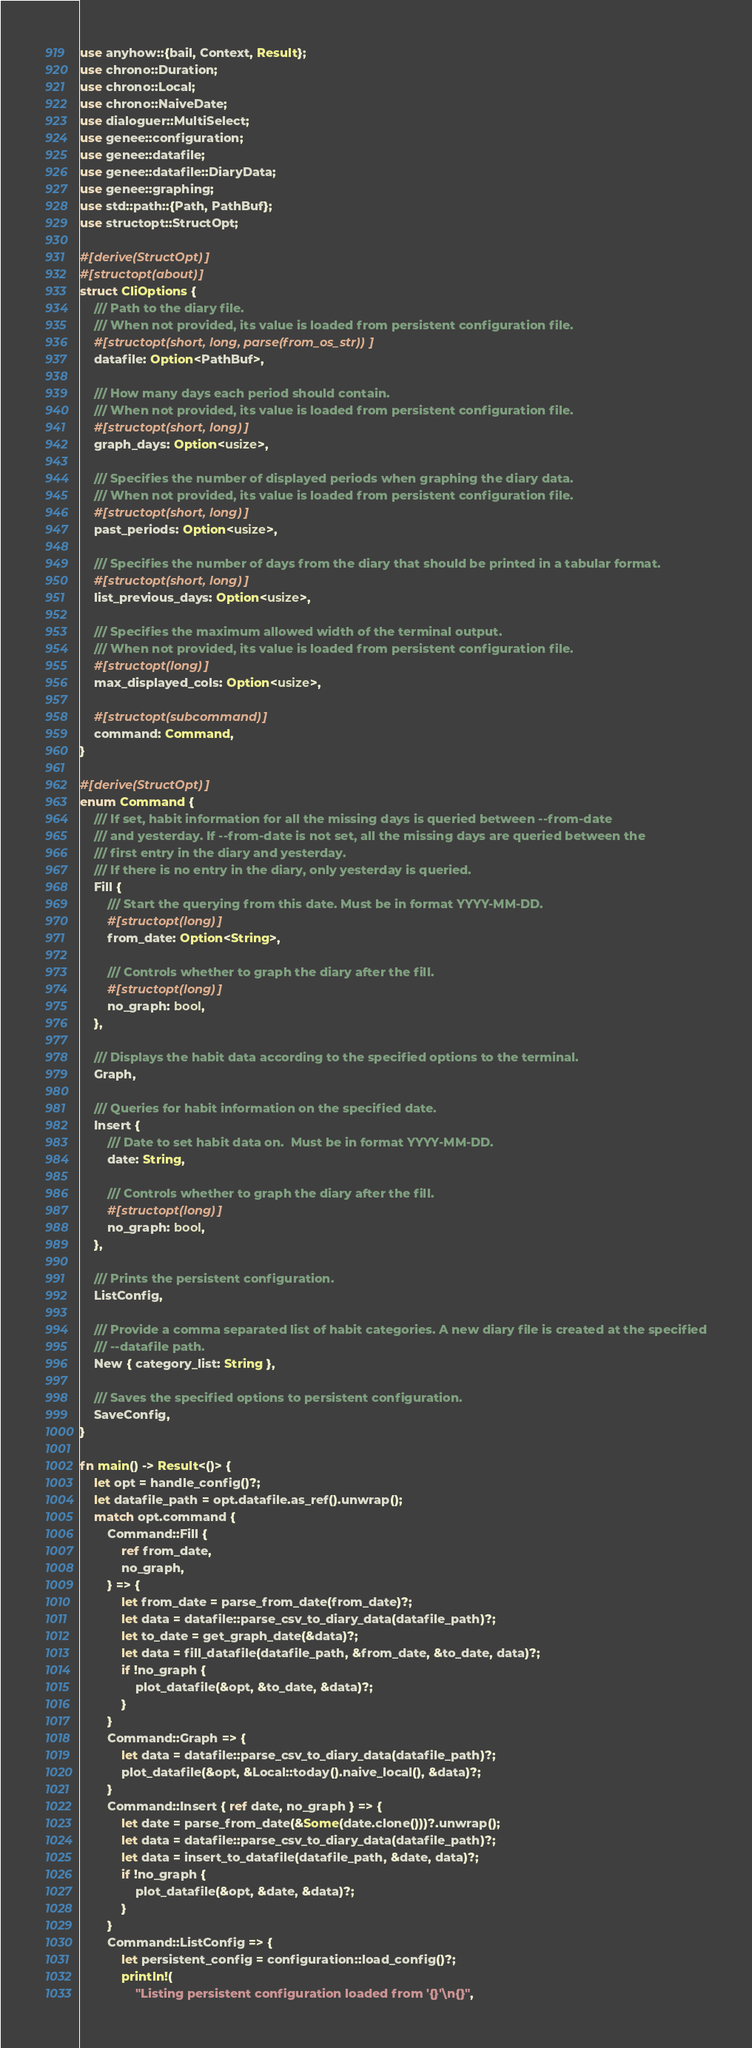Convert code to text. <code><loc_0><loc_0><loc_500><loc_500><_Rust_>use anyhow::{bail, Context, Result};
use chrono::Duration;
use chrono::Local;
use chrono::NaiveDate;
use dialoguer::MultiSelect;
use genee::configuration;
use genee::datafile;
use genee::datafile::DiaryData;
use genee::graphing;
use std::path::{Path, PathBuf};
use structopt::StructOpt;

#[derive(StructOpt)]
#[structopt(about)]
struct CliOptions {
    /// Path to the diary file.
    /// When not provided, its value is loaded from persistent configuration file.
    #[structopt(short, long, parse(from_os_str))]
    datafile: Option<PathBuf>,

    /// How many days each period should contain.
    /// When not provided, its value is loaded from persistent configuration file.
    #[structopt(short, long)]
    graph_days: Option<usize>,

    /// Specifies the number of displayed periods when graphing the diary data.
    /// When not provided, its value is loaded from persistent configuration file.
    #[structopt(short, long)]
    past_periods: Option<usize>,

    /// Specifies the number of days from the diary that should be printed in a tabular format.
    #[structopt(short, long)]
    list_previous_days: Option<usize>,

    /// Specifies the maximum allowed width of the terminal output.
    /// When not provided, its value is loaded from persistent configuration file.
    #[structopt(long)]
    max_displayed_cols: Option<usize>,

    #[structopt(subcommand)]
    command: Command,
}

#[derive(StructOpt)]
enum Command {
    /// If set, habit information for all the missing days is queried between --from-date
    /// and yesterday. If --from-date is not set, all the missing days are queried between the
    /// first entry in the diary and yesterday.
    /// If there is no entry in the diary, only yesterday is queried.
    Fill {
        /// Start the querying from this date. Must be in format YYYY-MM-DD.
        #[structopt(long)]
        from_date: Option<String>,

        /// Controls whether to graph the diary after the fill.
        #[structopt(long)]
        no_graph: bool,
    },

    /// Displays the habit data according to the specified options to the terminal.
    Graph,

    /// Queries for habit information on the specified date.
    Insert {
        /// Date to set habit data on.  Must be in format YYYY-MM-DD.
        date: String,

        /// Controls whether to graph the diary after the fill.
        #[structopt(long)]
        no_graph: bool,
    },

    /// Prints the persistent configuration.
    ListConfig,

    /// Provide a comma separated list of habit categories. A new diary file is created at the specified
    /// --datafile path.
    New { category_list: String },

    /// Saves the specified options to persistent configuration.
    SaveConfig,
}

fn main() -> Result<()> {
    let opt = handle_config()?;
    let datafile_path = opt.datafile.as_ref().unwrap();
    match opt.command {
        Command::Fill {
            ref from_date,
            no_graph,
        } => {
            let from_date = parse_from_date(from_date)?;
            let data = datafile::parse_csv_to_diary_data(datafile_path)?;
            let to_date = get_graph_date(&data)?;
            let data = fill_datafile(datafile_path, &from_date, &to_date, data)?;
            if !no_graph {
                plot_datafile(&opt, &to_date, &data)?;
            }
        }
        Command::Graph => {
            let data = datafile::parse_csv_to_diary_data(datafile_path)?;
            plot_datafile(&opt, &Local::today().naive_local(), &data)?;
        }
        Command::Insert { ref date, no_graph } => {
            let date = parse_from_date(&Some(date.clone()))?.unwrap();
            let data = datafile::parse_csv_to_diary_data(datafile_path)?;
            let data = insert_to_datafile(datafile_path, &date, data)?;
            if !no_graph {
                plot_datafile(&opt, &date, &data)?;
            }
        }
        Command::ListConfig => {
            let persistent_config = configuration::load_config()?;
            println!(
                "Listing persistent configuration loaded from '{}'\n{}",</code> 